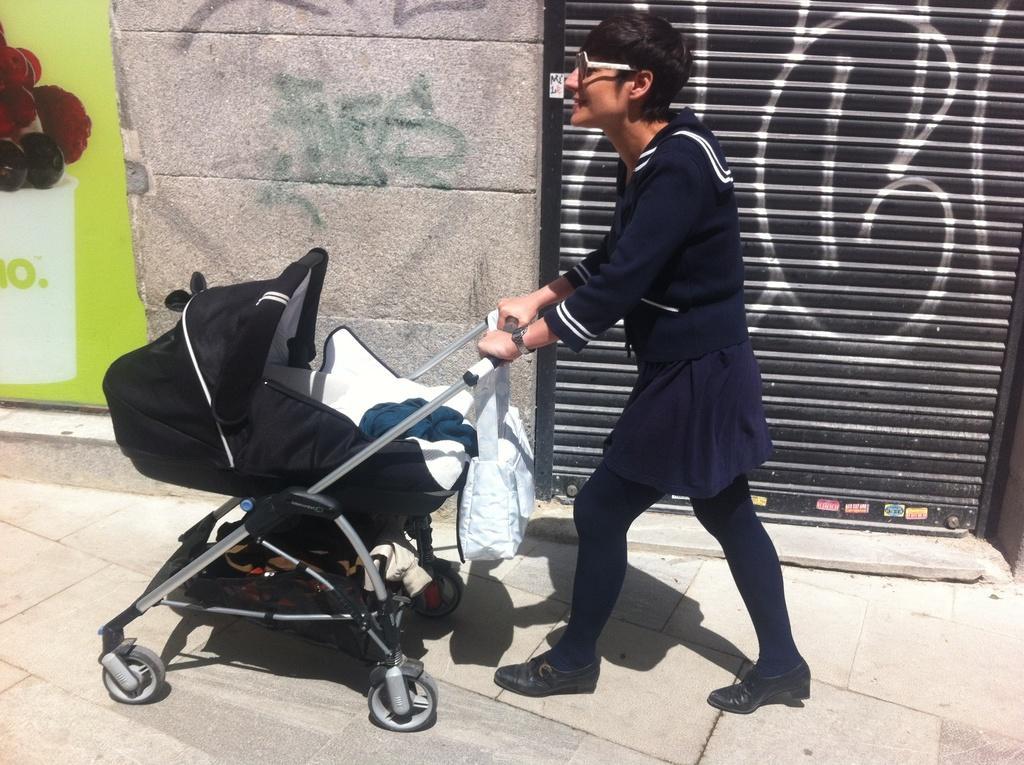Describe this image in one or two sentences. In this image I can see the person standing and holding the wheelchair. The wheelchair is in black and white color and the person is wearing the navy blue color dress. To the side of the person I can see the shutter and the wall. 